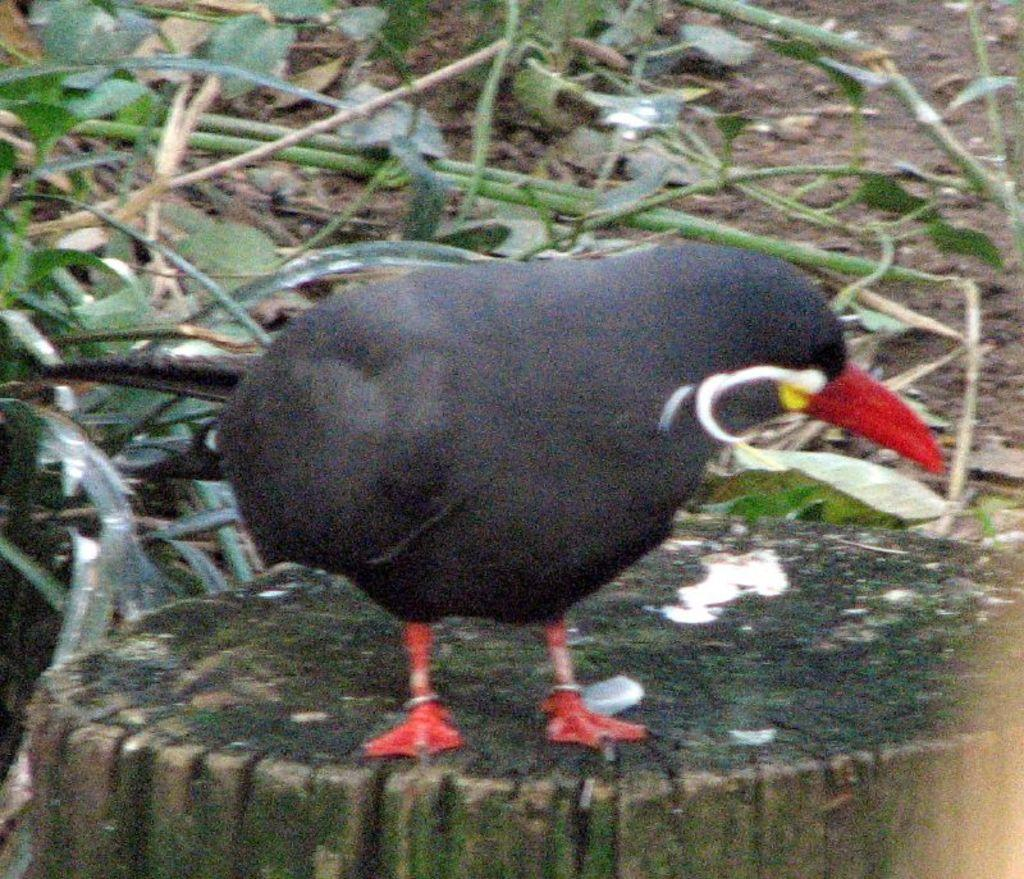What is the main subject of the picture? There is a bird in the center of the picture. Where is the bird located? The bird is on the trunk of a tree. What can be seen in the background of the image? There are stems, leaves, dry leaves, and soil visible in the background of the image. Reasoning: Let'g: Let's think step by step in order to produce the conversation. We start by identifying the main subject of the image, which is the bird. Then, we describe the bird's location, which is on the trunk of a tree. Finally, we expand the conversation to include other elements visible in the background of the image, such as stems, leaves, dry leaves, and soil. Absurd Question/Answer: What type of chickens can be seen playing during recess in the image? There are no chickens or any indication of recess present in the image; it features a bird on a tree trunk. 